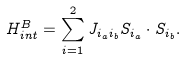<formula> <loc_0><loc_0><loc_500><loc_500>H ^ { B } _ { i n t } = \sum _ { i = 1 } ^ { 2 } J _ { i _ { a } i _ { b } } S _ { i _ { a } } \cdot S _ { i _ { b } } .</formula> 